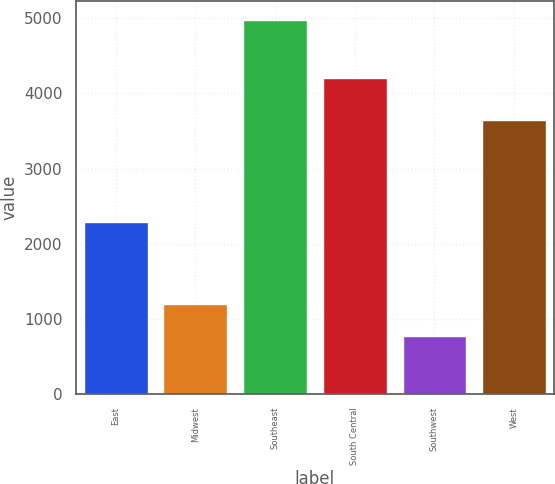<chart> <loc_0><loc_0><loc_500><loc_500><bar_chart><fcel>East<fcel>Midwest<fcel>Southeast<fcel>South Central<fcel>Southwest<fcel>West<nl><fcel>2290.2<fcel>1193.12<fcel>4977.8<fcel>4202.4<fcel>772.6<fcel>3650.8<nl></chart> 